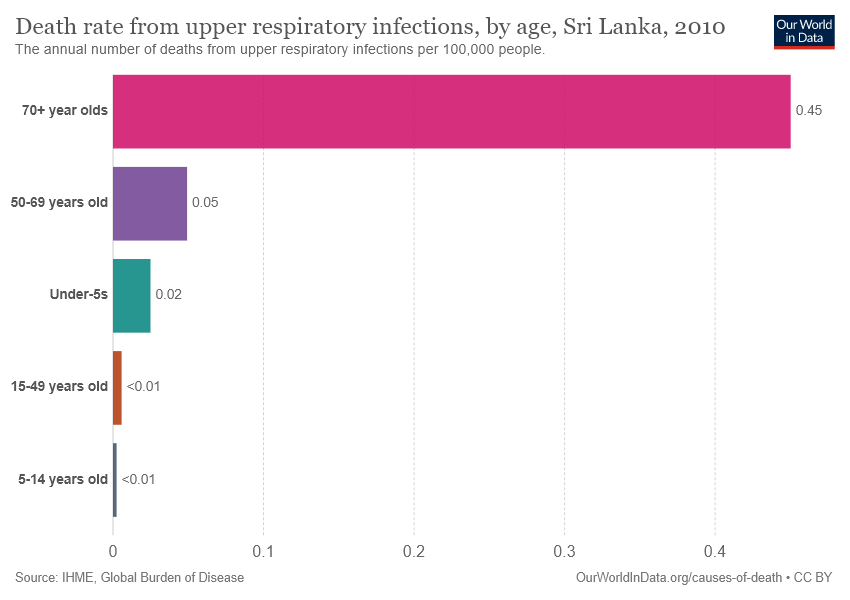Mention a couple of crucial points in this snapshot. According to the data provided, the two age groups with the least value are those of 5-14 years old and 15-49 years old. 